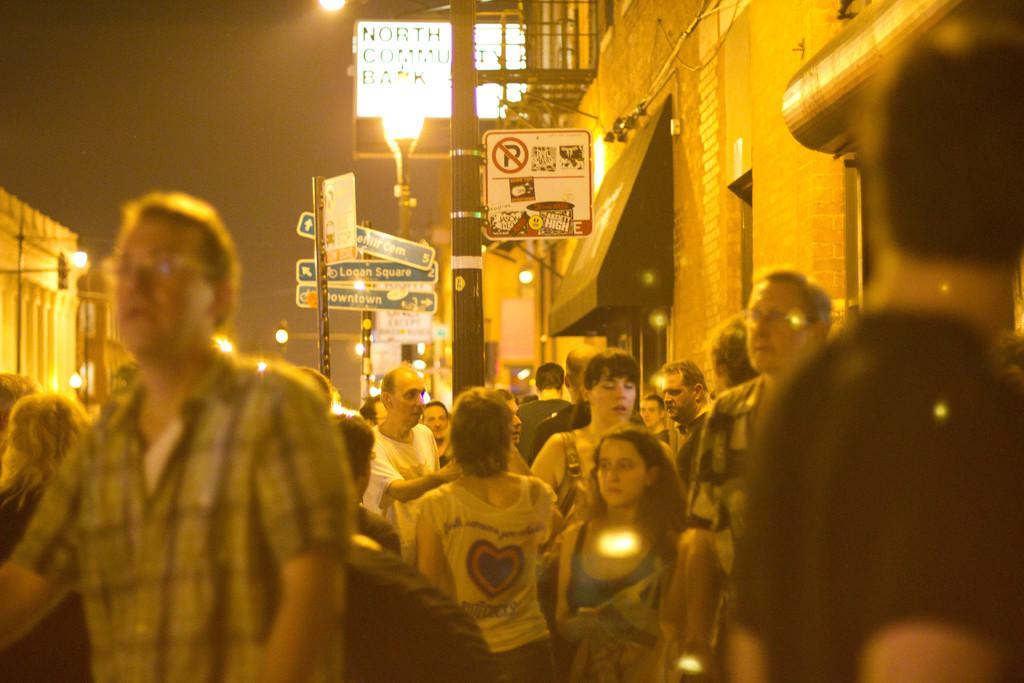What are the people in the image doing? The people in the image are walking on the streets. What can be seen on the sides of the streets? There are buildings on either side of the street in the image. What other objects can be seen in the image? There are sign boards and lampposts in the image. How many drawers are visible in the image? There are no drawers present in the image. What is the weight of the joke being told by the lamppost in the image? There is no joke being told by the lamppost in the image, and therefore no weight can be assigned to it. 